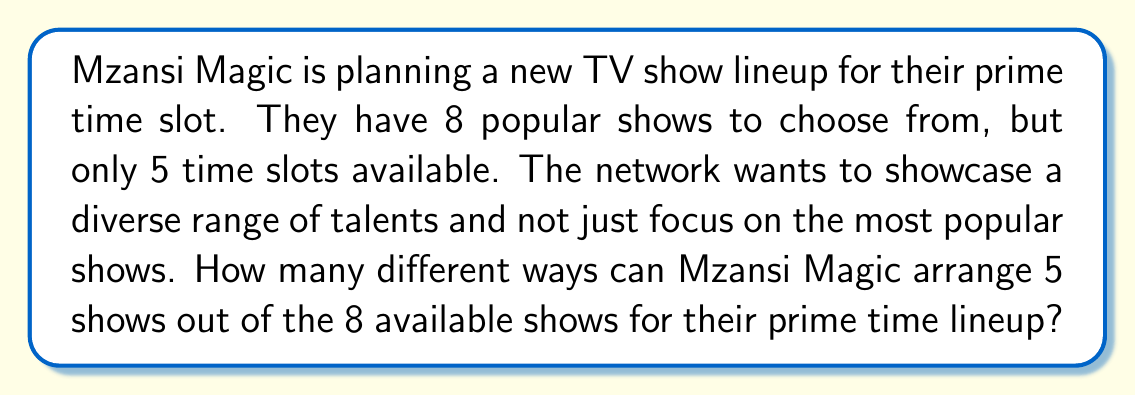Can you solve this math problem? To solve this problem, we need to use the concept of permutations. Permutations are used when we want to arrange objects in a specific order, and the order matters.

In this case:
- We have 8 shows to choose from (n = 8)
- We need to arrange 5 of them (r = 5)
- The order matters (as they are being arranged in specific time slots)

The formula for permutations when choosing r items from n items is:

$$P(n,r) = \frac{n!}{(n-r)!}$$

Where n! represents the factorial of n.

Let's plug in our values:

$$P(8,5) = \frac{8!}{(8-5)!} = \frac{8!}{3!}$$

Now, let's calculate this step by step:

1) First, expand 8!:
   $$\frac{8 \times 7 \times 6 \times 5 \times 4 \times 3!}{3!}$$

2) The 3! cancels out in the numerator and denominator:
   $$8 \times 7 \times 6 \times 5 \times 4 = 6720$$

Therefore, there are 6720 different ways to arrange 5 shows out of the 8 available shows for the prime time lineup.

This large number of possibilities allows Mzansi Magic to create diverse lineups, potentially giving less popular but talented shows a chance to shine in prime time slots.
Answer: 6720 different arrangements 